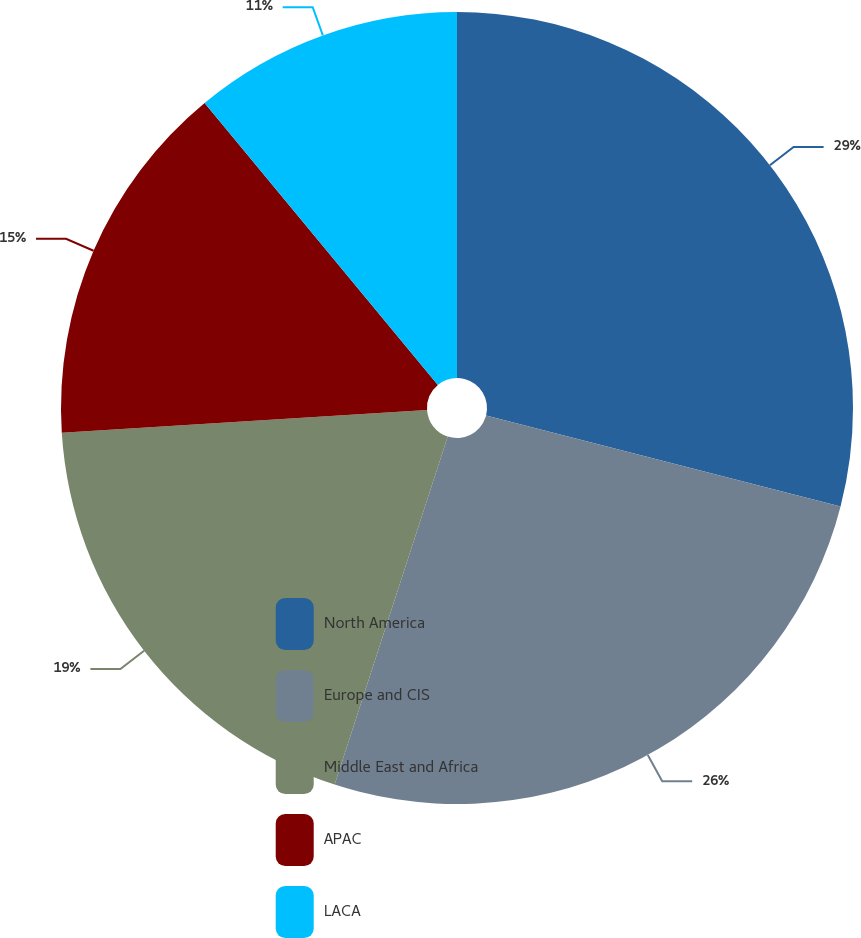Convert chart. <chart><loc_0><loc_0><loc_500><loc_500><pie_chart><fcel>North America<fcel>Europe and CIS<fcel>Middle East and Africa<fcel>APAC<fcel>LACA<nl><fcel>29.0%<fcel>26.0%<fcel>19.0%<fcel>15.0%<fcel>11.0%<nl></chart> 